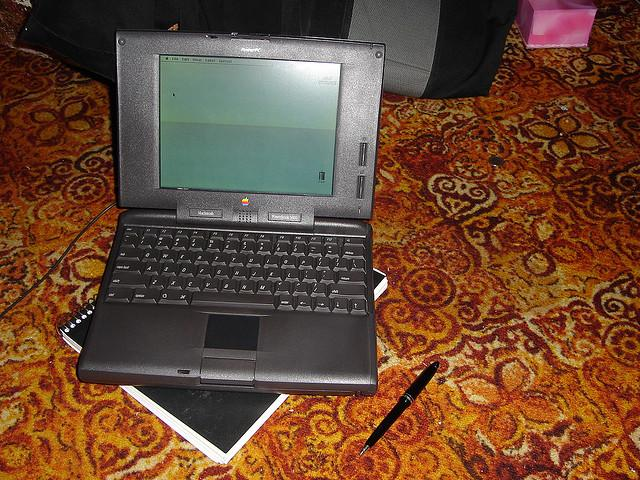What company made the black laptop on the black notebook?

Choices:
A) hp
B) dell
C) apple
D) sony apple 